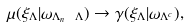<formula> <loc_0><loc_0><loc_500><loc_500>\mu ( \xi _ { \Lambda } | \omega _ { \Lambda _ { n } \ \Lambda } ) \to \gamma ( \xi _ { \Lambda } | \omega _ { \Lambda ^ { c } } ) ,</formula> 